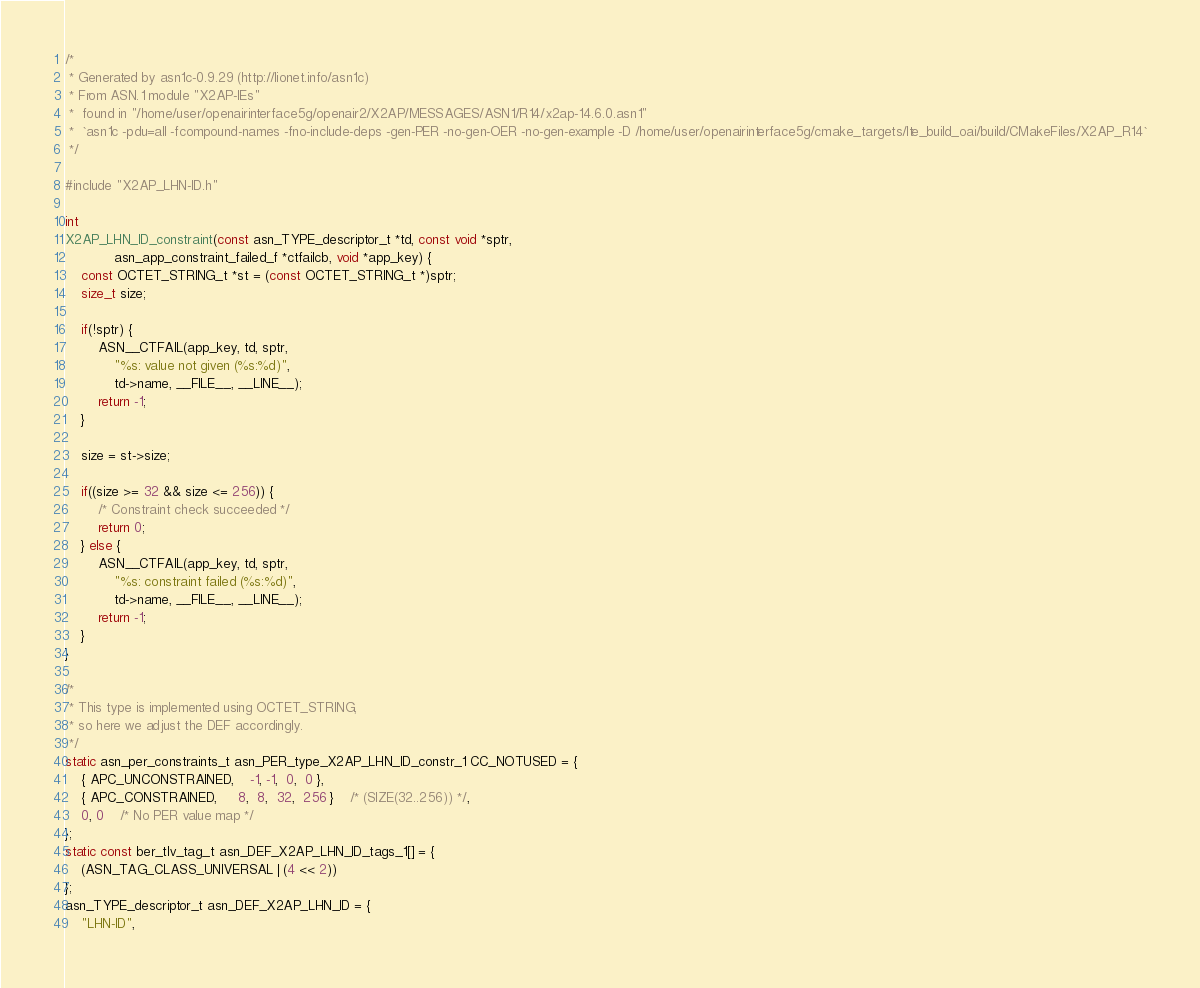<code> <loc_0><loc_0><loc_500><loc_500><_C_>/*
 * Generated by asn1c-0.9.29 (http://lionet.info/asn1c)
 * From ASN.1 module "X2AP-IEs"
 * 	found in "/home/user/openairinterface5g/openair2/X2AP/MESSAGES/ASN1/R14/x2ap-14.6.0.asn1"
 * 	`asn1c -pdu=all -fcompound-names -fno-include-deps -gen-PER -no-gen-OER -no-gen-example -D /home/user/openairinterface5g/cmake_targets/lte_build_oai/build/CMakeFiles/X2AP_R14`
 */

#include "X2AP_LHN-ID.h"

int
X2AP_LHN_ID_constraint(const asn_TYPE_descriptor_t *td, const void *sptr,
			asn_app_constraint_failed_f *ctfailcb, void *app_key) {
	const OCTET_STRING_t *st = (const OCTET_STRING_t *)sptr;
	size_t size;
	
	if(!sptr) {
		ASN__CTFAIL(app_key, td, sptr,
			"%s: value not given (%s:%d)",
			td->name, __FILE__, __LINE__);
		return -1;
	}
	
	size = st->size;
	
	if((size >= 32 && size <= 256)) {
		/* Constraint check succeeded */
		return 0;
	} else {
		ASN__CTFAIL(app_key, td, sptr,
			"%s: constraint failed (%s:%d)",
			td->name, __FILE__, __LINE__);
		return -1;
	}
}

/*
 * This type is implemented using OCTET_STRING,
 * so here we adjust the DEF accordingly.
 */
static asn_per_constraints_t asn_PER_type_X2AP_LHN_ID_constr_1 CC_NOTUSED = {
	{ APC_UNCONSTRAINED,	-1, -1,  0,  0 },
	{ APC_CONSTRAINED,	 8,  8,  32,  256 }	/* (SIZE(32..256)) */,
	0, 0	/* No PER value map */
};
static const ber_tlv_tag_t asn_DEF_X2AP_LHN_ID_tags_1[] = {
	(ASN_TAG_CLASS_UNIVERSAL | (4 << 2))
};
asn_TYPE_descriptor_t asn_DEF_X2AP_LHN_ID = {
	"LHN-ID",</code> 